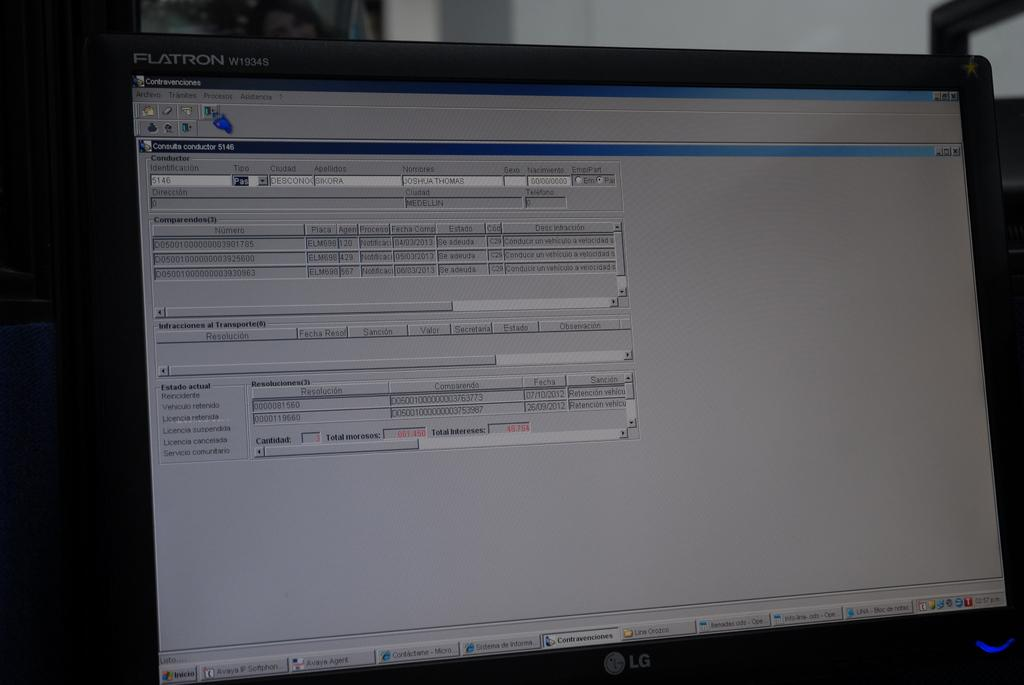<image>
Present a compact description of the photo's key features. A computer monitor displaying some information in spanish. 